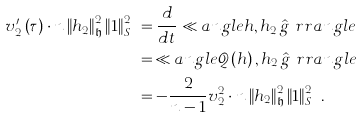Convert formula to latex. <formula><loc_0><loc_0><loc_500><loc_500>v _ { 2 } ^ { \prime } \left ( \tau \right ) \cdot n \left \| h _ { 2 } \right \| _ { \mathfrak { h } } ^ { 2 } \left \| 1 \right \| _ { S ^ { n } } ^ { 2 } & = \frac { d } { d t } \ll a n g l e h , h _ { 2 } \, \hat { g } \ r r a n g l e \\ & = \, \ll a n g l e \mathcal { Q } \left ( h \right ) , h _ { 2 } \, \hat { g } \ r r a n g l e \\ & = - \frac { 2 } { n - 1 } v _ { 2 } ^ { 2 } \cdot n \left \| h _ { 2 } \right \| _ { \mathfrak { h } } ^ { 2 } \left \| 1 \right \| _ { S ^ { n } } ^ { 2 } .</formula> 